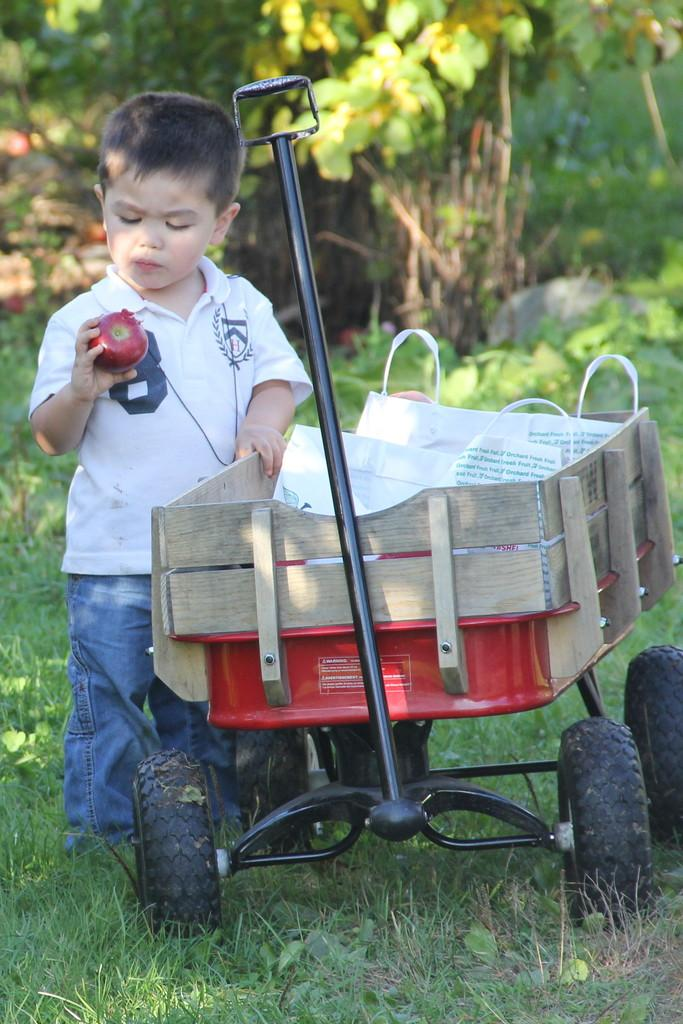Who is the main subject in the image? There is a boy in the image. What is the boy doing in the image? The boy is holding objects in the image. What can be seen in the background of the image? There is a carrier and grassy land in the image. What type of environment is depicted in the image? There are many plants in the image, suggesting a natural or outdoor setting. Is the boy in the image receiving any payment for his actions? There is no indication in the image that the boy is receiving any payment. 